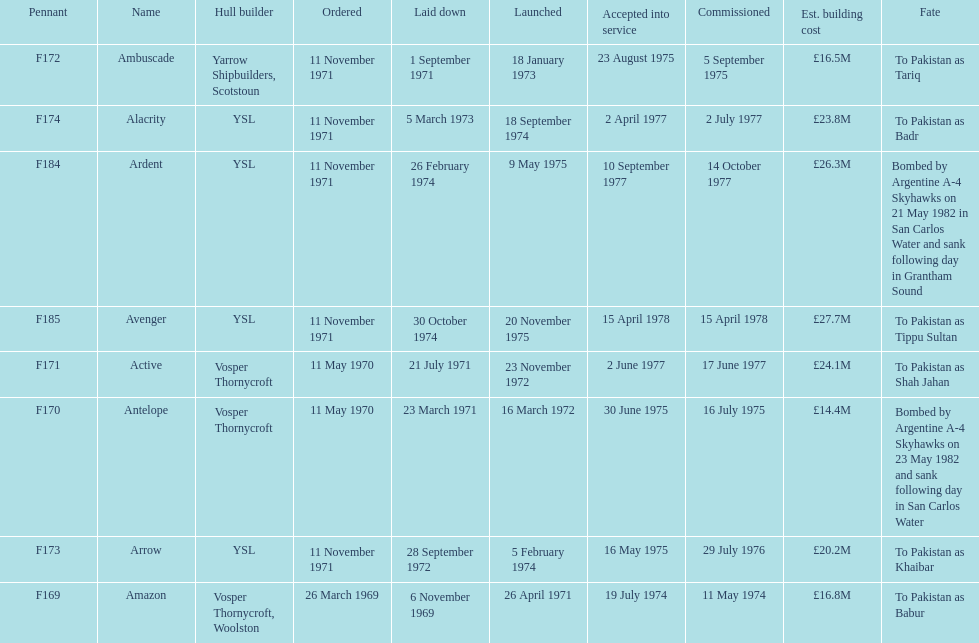What is the final mentioned pennant? F185. 